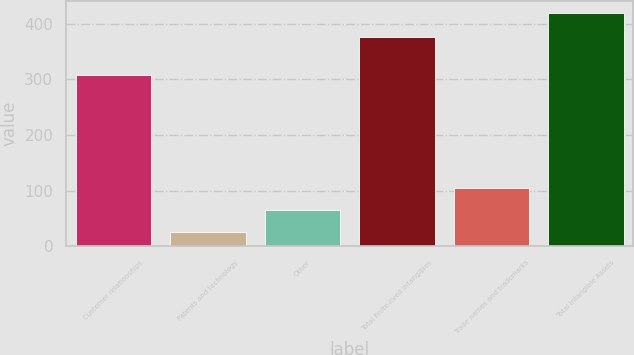<chart> <loc_0><loc_0><loc_500><loc_500><bar_chart><fcel>Customer relationships<fcel>Patents and technology<fcel>Other<fcel>Total finite-lived intangibles<fcel>Trade names and trademarks<fcel>Total Intangible Assets<nl><fcel>308.1<fcel>25.7<fcel>65.08<fcel>375.4<fcel>104.46<fcel>419.5<nl></chart> 